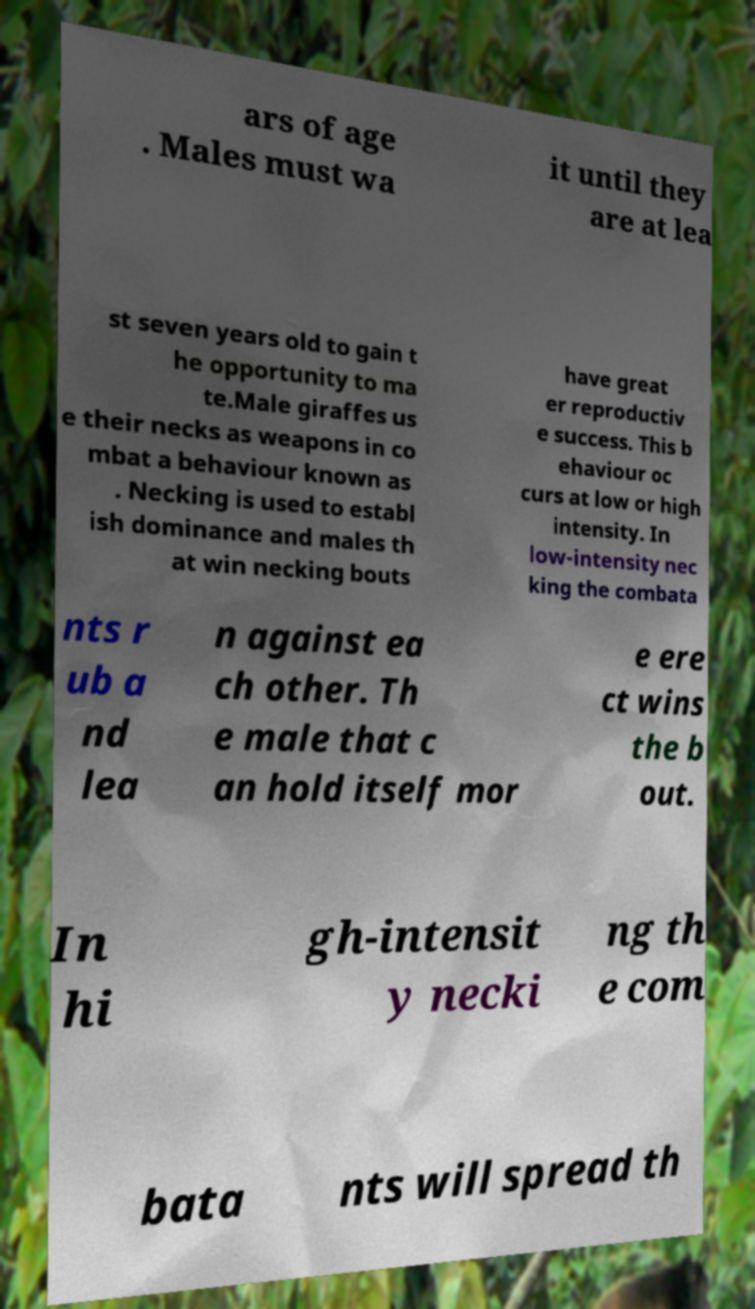What messages or text are displayed in this image? I need them in a readable, typed format. ars of age . Males must wa it until they are at lea st seven years old to gain t he opportunity to ma te.Male giraffes us e their necks as weapons in co mbat a behaviour known as . Necking is used to establ ish dominance and males th at win necking bouts have great er reproductiv e success. This b ehaviour oc curs at low or high intensity. In low-intensity nec king the combata nts r ub a nd lea n against ea ch other. Th e male that c an hold itself mor e ere ct wins the b out. In hi gh-intensit y necki ng th e com bata nts will spread th 